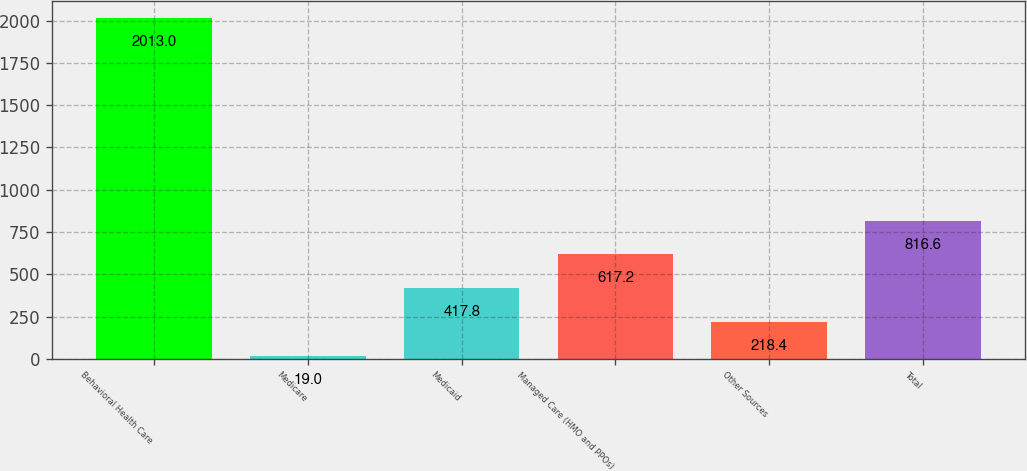<chart> <loc_0><loc_0><loc_500><loc_500><bar_chart><fcel>Behavioral Health Care<fcel>Medicare<fcel>Medicaid<fcel>Managed Care (HMO and PPOs)<fcel>Other Sources<fcel>Total<nl><fcel>2013<fcel>19<fcel>417.8<fcel>617.2<fcel>218.4<fcel>816.6<nl></chart> 